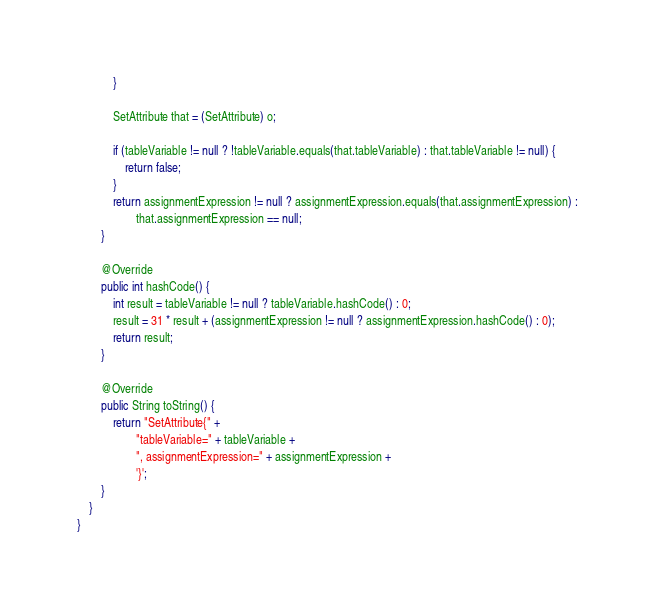<code> <loc_0><loc_0><loc_500><loc_500><_Java_>            }

            SetAttribute that = (SetAttribute) o;

            if (tableVariable != null ? !tableVariable.equals(that.tableVariable) : that.tableVariable != null) {
                return false;
            }
            return assignmentExpression != null ? assignmentExpression.equals(that.assignmentExpression) :
                    that.assignmentExpression == null;
        }

        @Override
        public int hashCode() {
            int result = tableVariable != null ? tableVariable.hashCode() : 0;
            result = 31 * result + (assignmentExpression != null ? assignmentExpression.hashCode() : 0);
            return result;
        }

        @Override
        public String toString() {
            return "SetAttribute{" +
                    "tableVariable=" + tableVariable +
                    ", assignmentExpression=" + assignmentExpression +
                    '}';
        }
    }
}
</code> 